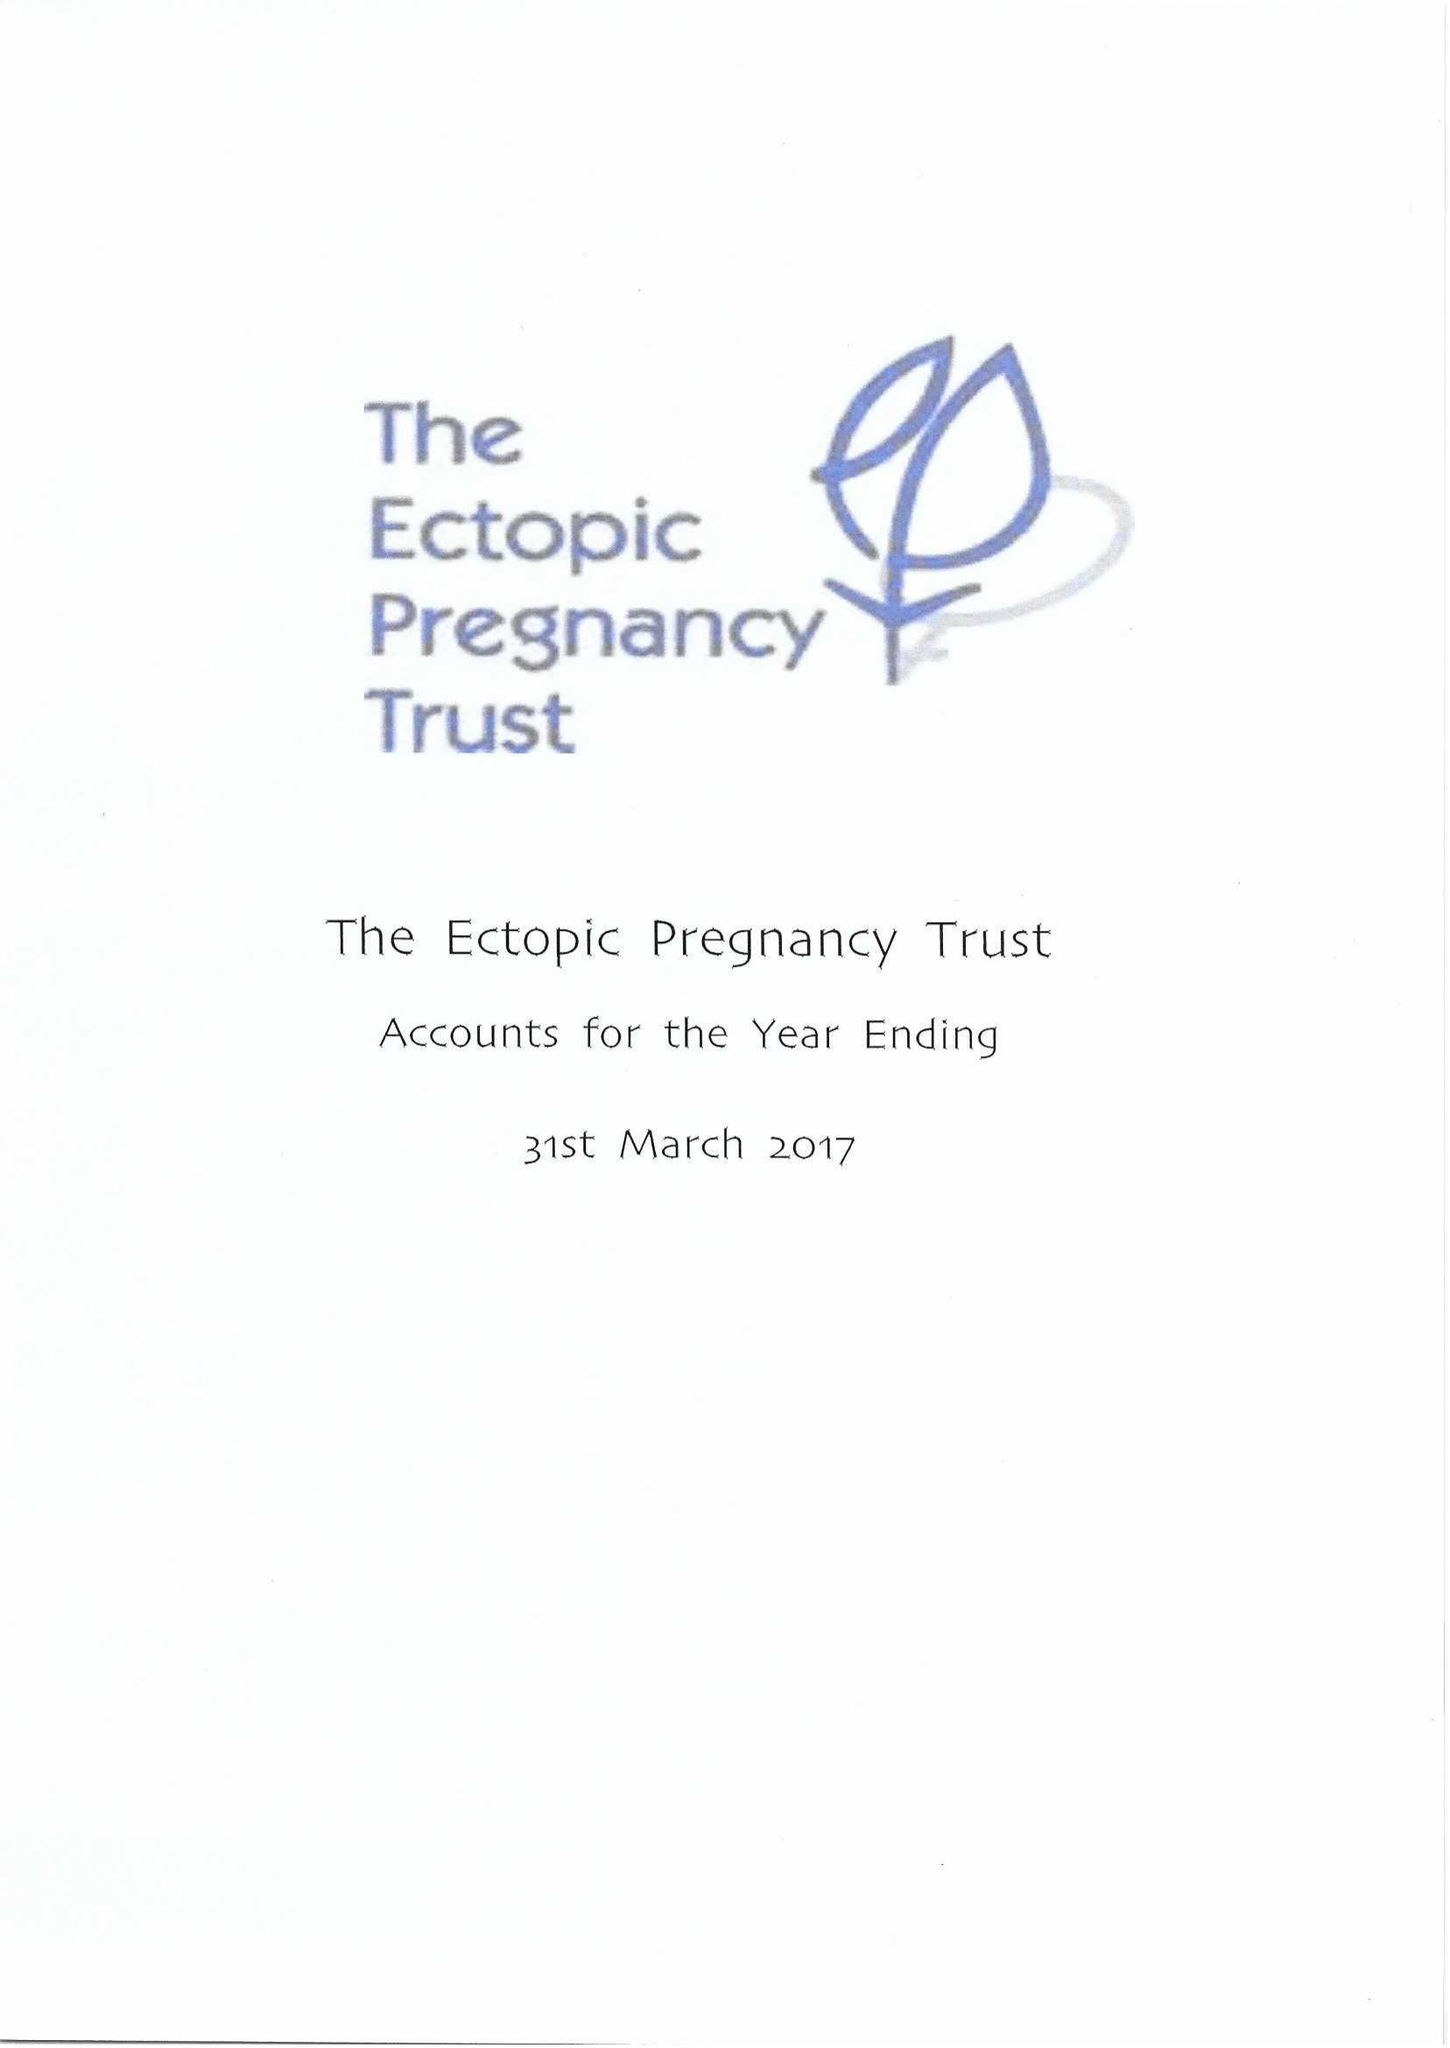What is the value for the charity_number?
Answer the question using a single word or phrase. 1071811 